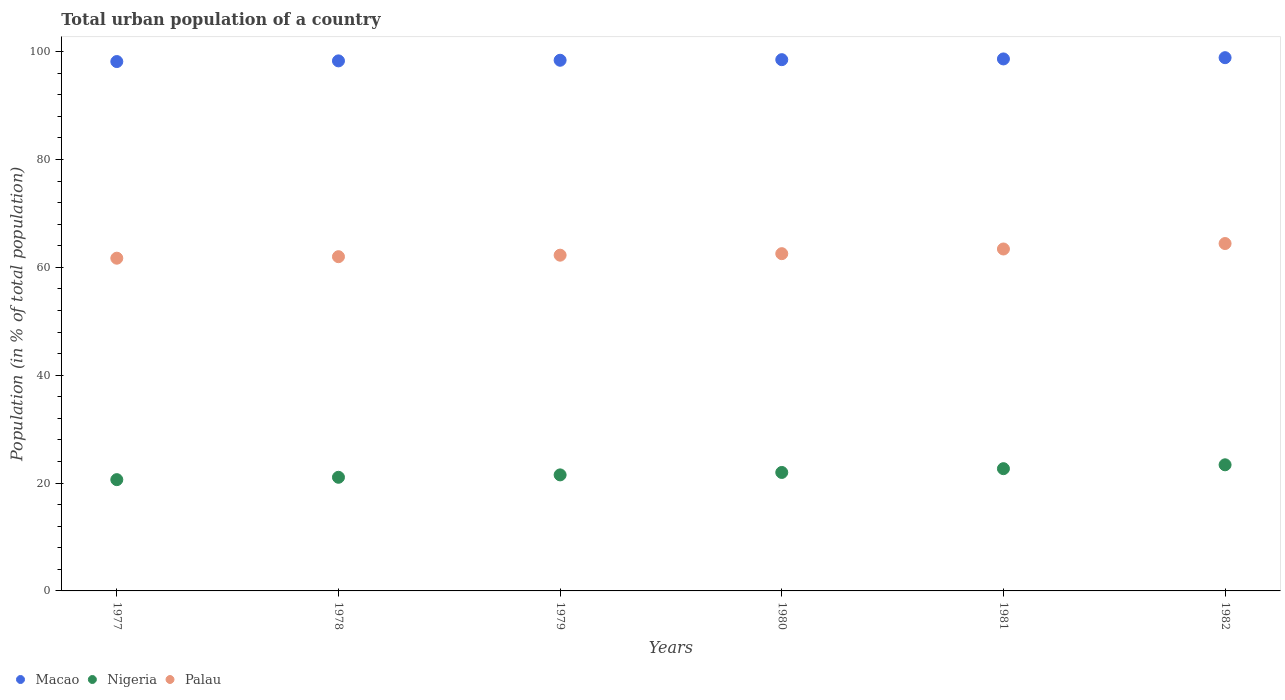What is the urban population in Palau in 1979?
Your answer should be compact. 62.26. Across all years, what is the maximum urban population in Nigeria?
Ensure brevity in your answer.  23.39. Across all years, what is the minimum urban population in Palau?
Your answer should be very brief. 61.7. In which year was the urban population in Palau maximum?
Your answer should be very brief. 1982. What is the total urban population in Palau in the graph?
Your answer should be very brief. 376.32. What is the difference between the urban population in Palau in 1979 and that in 1982?
Offer a very short reply. -2.16. What is the difference between the urban population in Macao in 1981 and the urban population in Nigeria in 1980?
Your answer should be very brief. 76.69. What is the average urban population in Nigeria per year?
Give a very brief answer. 21.88. In the year 1979, what is the difference between the urban population in Palau and urban population in Macao?
Your response must be concise. -36.15. In how many years, is the urban population in Nigeria greater than 40 %?
Offer a terse response. 0. What is the ratio of the urban population in Nigeria in 1979 to that in 1982?
Give a very brief answer. 0.92. What is the difference between the highest and the second highest urban population in Nigeria?
Give a very brief answer. 0.72. What is the difference between the highest and the lowest urban population in Nigeria?
Ensure brevity in your answer.  2.75. In how many years, is the urban population in Palau greater than the average urban population in Palau taken over all years?
Keep it short and to the point. 2. Does the urban population in Nigeria monotonically increase over the years?
Offer a terse response. Yes. How many dotlines are there?
Give a very brief answer. 3. What is the difference between two consecutive major ticks on the Y-axis?
Your answer should be compact. 20. Does the graph contain any zero values?
Provide a succinct answer. No. Where does the legend appear in the graph?
Offer a very short reply. Bottom left. How many legend labels are there?
Your answer should be compact. 3. How are the legend labels stacked?
Your response must be concise. Horizontal. What is the title of the graph?
Your answer should be compact. Total urban population of a country. Does "Least developed countries" appear as one of the legend labels in the graph?
Your answer should be compact. No. What is the label or title of the Y-axis?
Your response must be concise. Population (in % of total population). What is the Population (in % of total population) of Macao in 1977?
Your answer should be very brief. 98.17. What is the Population (in % of total population) in Nigeria in 1977?
Offer a very short reply. 20.64. What is the Population (in % of total population) of Palau in 1977?
Give a very brief answer. 61.7. What is the Population (in % of total population) in Macao in 1978?
Offer a terse response. 98.29. What is the Population (in % of total population) of Nigeria in 1978?
Offer a very short reply. 21.07. What is the Population (in % of total population) in Palau in 1978?
Keep it short and to the point. 61.98. What is the Population (in % of total population) of Macao in 1979?
Provide a succinct answer. 98.41. What is the Population (in % of total population) in Nigeria in 1979?
Your answer should be compact. 21.52. What is the Population (in % of total population) in Palau in 1979?
Give a very brief answer. 62.26. What is the Population (in % of total population) of Macao in 1980?
Your answer should be very brief. 98.52. What is the Population (in % of total population) of Nigeria in 1980?
Make the answer very short. 21.97. What is the Population (in % of total population) of Palau in 1980?
Provide a succinct answer. 62.54. What is the Population (in % of total population) in Macao in 1981?
Your answer should be very brief. 98.66. What is the Population (in % of total population) in Nigeria in 1981?
Offer a terse response. 22.67. What is the Population (in % of total population) in Palau in 1981?
Ensure brevity in your answer.  63.41. What is the Population (in % of total population) of Macao in 1982?
Offer a very short reply. 98.89. What is the Population (in % of total population) in Nigeria in 1982?
Keep it short and to the point. 23.39. What is the Population (in % of total population) of Palau in 1982?
Ensure brevity in your answer.  64.42. Across all years, what is the maximum Population (in % of total population) of Macao?
Make the answer very short. 98.89. Across all years, what is the maximum Population (in % of total population) in Nigeria?
Offer a terse response. 23.39. Across all years, what is the maximum Population (in % of total population) in Palau?
Your response must be concise. 64.42. Across all years, what is the minimum Population (in % of total population) of Macao?
Your answer should be very brief. 98.17. Across all years, what is the minimum Population (in % of total population) of Nigeria?
Offer a very short reply. 20.64. Across all years, what is the minimum Population (in % of total population) of Palau?
Ensure brevity in your answer.  61.7. What is the total Population (in % of total population) in Macao in the graph?
Offer a very short reply. 590.94. What is the total Population (in % of total population) of Nigeria in the graph?
Offer a very short reply. 131.26. What is the total Population (in % of total population) of Palau in the graph?
Offer a very short reply. 376.32. What is the difference between the Population (in % of total population) in Macao in 1977 and that in 1978?
Keep it short and to the point. -0.12. What is the difference between the Population (in % of total population) of Nigeria in 1977 and that in 1978?
Your response must be concise. -0.44. What is the difference between the Population (in % of total population) of Palau in 1977 and that in 1978?
Your answer should be compact. -0.28. What is the difference between the Population (in % of total population) of Macao in 1977 and that in 1979?
Your answer should be compact. -0.24. What is the difference between the Population (in % of total population) in Nigeria in 1977 and that in 1979?
Make the answer very short. -0.88. What is the difference between the Population (in % of total population) of Palau in 1977 and that in 1979?
Make the answer very short. -0.56. What is the difference between the Population (in % of total population) of Macao in 1977 and that in 1980?
Provide a succinct answer. -0.35. What is the difference between the Population (in % of total population) of Nigeria in 1977 and that in 1980?
Your answer should be compact. -1.33. What is the difference between the Population (in % of total population) of Palau in 1977 and that in 1980?
Ensure brevity in your answer.  -0.84. What is the difference between the Population (in % of total population) in Macao in 1977 and that in 1981?
Provide a succinct answer. -0.49. What is the difference between the Population (in % of total population) in Nigeria in 1977 and that in 1981?
Ensure brevity in your answer.  -2.04. What is the difference between the Population (in % of total population) in Palau in 1977 and that in 1981?
Offer a terse response. -1.71. What is the difference between the Population (in % of total population) of Macao in 1977 and that in 1982?
Provide a short and direct response. -0.72. What is the difference between the Population (in % of total population) in Nigeria in 1977 and that in 1982?
Ensure brevity in your answer.  -2.75. What is the difference between the Population (in % of total population) of Palau in 1977 and that in 1982?
Provide a short and direct response. -2.72. What is the difference between the Population (in % of total population) of Macao in 1978 and that in 1979?
Your answer should be compact. -0.12. What is the difference between the Population (in % of total population) of Nigeria in 1978 and that in 1979?
Make the answer very short. -0.44. What is the difference between the Population (in % of total population) of Palau in 1978 and that in 1979?
Make the answer very short. -0.28. What is the difference between the Population (in % of total population) of Macao in 1978 and that in 1980?
Provide a succinct answer. -0.23. What is the difference between the Population (in % of total population) in Nigeria in 1978 and that in 1980?
Provide a succinct answer. -0.9. What is the difference between the Population (in % of total population) in Palau in 1978 and that in 1980?
Your response must be concise. -0.56. What is the difference between the Population (in % of total population) in Macao in 1978 and that in 1981?
Offer a terse response. -0.36. What is the difference between the Population (in % of total population) in Nigeria in 1978 and that in 1981?
Offer a terse response. -1.6. What is the difference between the Population (in % of total population) of Palau in 1978 and that in 1981?
Your answer should be very brief. -1.43. What is the difference between the Population (in % of total population) of Macao in 1978 and that in 1982?
Make the answer very short. -0.59. What is the difference between the Population (in % of total population) of Nigeria in 1978 and that in 1982?
Ensure brevity in your answer.  -2.31. What is the difference between the Population (in % of total population) in Palau in 1978 and that in 1982?
Make the answer very short. -2.44. What is the difference between the Population (in % of total population) in Macao in 1979 and that in 1980?
Your answer should be very brief. -0.11. What is the difference between the Population (in % of total population) in Nigeria in 1979 and that in 1980?
Ensure brevity in your answer.  -0.45. What is the difference between the Population (in % of total population) of Palau in 1979 and that in 1980?
Make the answer very short. -0.28. What is the difference between the Population (in % of total population) in Macao in 1979 and that in 1981?
Provide a short and direct response. -0.24. What is the difference between the Population (in % of total population) of Nigeria in 1979 and that in 1981?
Make the answer very short. -1.15. What is the difference between the Population (in % of total population) of Palau in 1979 and that in 1981?
Your response must be concise. -1.15. What is the difference between the Population (in % of total population) of Macao in 1979 and that in 1982?
Your answer should be very brief. -0.48. What is the difference between the Population (in % of total population) of Nigeria in 1979 and that in 1982?
Offer a very short reply. -1.87. What is the difference between the Population (in % of total population) in Palau in 1979 and that in 1982?
Make the answer very short. -2.16. What is the difference between the Population (in % of total population) of Macao in 1980 and that in 1981?
Provide a short and direct response. -0.14. What is the difference between the Population (in % of total population) of Nigeria in 1980 and that in 1981?
Provide a short and direct response. -0.7. What is the difference between the Population (in % of total population) of Palau in 1980 and that in 1981?
Your response must be concise. -0.87. What is the difference between the Population (in % of total population) of Macao in 1980 and that in 1982?
Ensure brevity in your answer.  -0.37. What is the difference between the Population (in % of total population) in Nigeria in 1980 and that in 1982?
Provide a short and direct response. -1.42. What is the difference between the Population (in % of total population) in Palau in 1980 and that in 1982?
Ensure brevity in your answer.  -1.88. What is the difference between the Population (in % of total population) in Macao in 1981 and that in 1982?
Your answer should be very brief. -0.23. What is the difference between the Population (in % of total population) of Nigeria in 1981 and that in 1982?
Your answer should be very brief. -0.72. What is the difference between the Population (in % of total population) in Palau in 1981 and that in 1982?
Your response must be concise. -1.01. What is the difference between the Population (in % of total population) of Macao in 1977 and the Population (in % of total population) of Nigeria in 1978?
Your answer should be very brief. 77.09. What is the difference between the Population (in % of total population) of Macao in 1977 and the Population (in % of total population) of Palau in 1978?
Your answer should be compact. 36.19. What is the difference between the Population (in % of total population) in Nigeria in 1977 and the Population (in % of total population) in Palau in 1978?
Your response must be concise. -41.35. What is the difference between the Population (in % of total population) in Macao in 1977 and the Population (in % of total population) in Nigeria in 1979?
Your response must be concise. 76.65. What is the difference between the Population (in % of total population) of Macao in 1977 and the Population (in % of total population) of Palau in 1979?
Your response must be concise. 35.91. What is the difference between the Population (in % of total population) of Nigeria in 1977 and the Population (in % of total population) of Palau in 1979?
Provide a succinct answer. -41.63. What is the difference between the Population (in % of total population) in Macao in 1977 and the Population (in % of total population) in Nigeria in 1980?
Provide a succinct answer. 76.2. What is the difference between the Population (in % of total population) in Macao in 1977 and the Population (in % of total population) in Palau in 1980?
Offer a terse response. 35.63. What is the difference between the Population (in % of total population) in Nigeria in 1977 and the Population (in % of total population) in Palau in 1980?
Give a very brief answer. -41.91. What is the difference between the Population (in % of total population) of Macao in 1977 and the Population (in % of total population) of Nigeria in 1981?
Offer a terse response. 75.5. What is the difference between the Population (in % of total population) in Macao in 1977 and the Population (in % of total population) in Palau in 1981?
Offer a terse response. 34.76. What is the difference between the Population (in % of total population) of Nigeria in 1977 and the Population (in % of total population) of Palau in 1981?
Provide a succinct answer. -42.77. What is the difference between the Population (in % of total population) of Macao in 1977 and the Population (in % of total population) of Nigeria in 1982?
Give a very brief answer. 74.78. What is the difference between the Population (in % of total population) of Macao in 1977 and the Population (in % of total population) of Palau in 1982?
Your answer should be compact. 33.75. What is the difference between the Population (in % of total population) in Nigeria in 1977 and the Population (in % of total population) in Palau in 1982?
Keep it short and to the point. -43.79. What is the difference between the Population (in % of total population) in Macao in 1978 and the Population (in % of total population) in Nigeria in 1979?
Keep it short and to the point. 76.78. What is the difference between the Population (in % of total population) in Macao in 1978 and the Population (in % of total population) in Palau in 1979?
Offer a very short reply. 36.03. What is the difference between the Population (in % of total population) of Nigeria in 1978 and the Population (in % of total population) of Palau in 1979?
Provide a short and direct response. -41.19. What is the difference between the Population (in % of total population) in Macao in 1978 and the Population (in % of total population) in Nigeria in 1980?
Provide a short and direct response. 76.32. What is the difference between the Population (in % of total population) in Macao in 1978 and the Population (in % of total population) in Palau in 1980?
Give a very brief answer. 35.75. What is the difference between the Population (in % of total population) of Nigeria in 1978 and the Population (in % of total population) of Palau in 1980?
Make the answer very short. -41.47. What is the difference between the Population (in % of total population) in Macao in 1978 and the Population (in % of total population) in Nigeria in 1981?
Provide a succinct answer. 75.62. What is the difference between the Population (in % of total population) in Macao in 1978 and the Population (in % of total population) in Palau in 1981?
Your answer should be compact. 34.88. What is the difference between the Population (in % of total population) of Nigeria in 1978 and the Population (in % of total population) of Palau in 1981?
Provide a short and direct response. -42.34. What is the difference between the Population (in % of total population) of Macao in 1978 and the Population (in % of total population) of Nigeria in 1982?
Ensure brevity in your answer.  74.91. What is the difference between the Population (in % of total population) in Macao in 1978 and the Population (in % of total population) in Palau in 1982?
Offer a very short reply. 33.87. What is the difference between the Population (in % of total population) of Nigeria in 1978 and the Population (in % of total population) of Palau in 1982?
Your response must be concise. -43.35. What is the difference between the Population (in % of total population) in Macao in 1979 and the Population (in % of total population) in Nigeria in 1980?
Give a very brief answer. 76.44. What is the difference between the Population (in % of total population) of Macao in 1979 and the Population (in % of total population) of Palau in 1980?
Offer a terse response. 35.87. What is the difference between the Population (in % of total population) in Nigeria in 1979 and the Population (in % of total population) in Palau in 1980?
Provide a succinct answer. -41.02. What is the difference between the Population (in % of total population) of Macao in 1979 and the Population (in % of total population) of Nigeria in 1981?
Your answer should be very brief. 75.74. What is the difference between the Population (in % of total population) of Macao in 1979 and the Population (in % of total population) of Palau in 1981?
Ensure brevity in your answer.  35. What is the difference between the Population (in % of total population) in Nigeria in 1979 and the Population (in % of total population) in Palau in 1981?
Ensure brevity in your answer.  -41.89. What is the difference between the Population (in % of total population) of Macao in 1979 and the Population (in % of total population) of Nigeria in 1982?
Ensure brevity in your answer.  75.02. What is the difference between the Population (in % of total population) of Macao in 1979 and the Population (in % of total population) of Palau in 1982?
Give a very brief answer. 33.99. What is the difference between the Population (in % of total population) of Nigeria in 1979 and the Population (in % of total population) of Palau in 1982?
Ensure brevity in your answer.  -42.9. What is the difference between the Population (in % of total population) of Macao in 1980 and the Population (in % of total population) of Nigeria in 1981?
Provide a succinct answer. 75.85. What is the difference between the Population (in % of total population) of Macao in 1980 and the Population (in % of total population) of Palau in 1981?
Offer a terse response. 35.11. What is the difference between the Population (in % of total population) in Nigeria in 1980 and the Population (in % of total population) in Palau in 1981?
Make the answer very short. -41.44. What is the difference between the Population (in % of total population) in Macao in 1980 and the Population (in % of total population) in Nigeria in 1982?
Provide a short and direct response. 75.13. What is the difference between the Population (in % of total population) of Macao in 1980 and the Population (in % of total population) of Palau in 1982?
Offer a very short reply. 34.1. What is the difference between the Population (in % of total population) in Nigeria in 1980 and the Population (in % of total population) in Palau in 1982?
Make the answer very short. -42.45. What is the difference between the Population (in % of total population) of Macao in 1981 and the Population (in % of total population) of Nigeria in 1982?
Keep it short and to the point. 75.27. What is the difference between the Population (in % of total population) in Macao in 1981 and the Population (in % of total population) in Palau in 1982?
Give a very brief answer. 34.23. What is the difference between the Population (in % of total population) of Nigeria in 1981 and the Population (in % of total population) of Palau in 1982?
Provide a short and direct response. -41.75. What is the average Population (in % of total population) in Macao per year?
Give a very brief answer. 98.49. What is the average Population (in % of total population) of Nigeria per year?
Your answer should be compact. 21.88. What is the average Population (in % of total population) in Palau per year?
Offer a terse response. 62.72. In the year 1977, what is the difference between the Population (in % of total population) in Macao and Population (in % of total population) in Nigeria?
Provide a short and direct response. 77.53. In the year 1977, what is the difference between the Population (in % of total population) of Macao and Population (in % of total population) of Palau?
Your answer should be compact. 36.47. In the year 1977, what is the difference between the Population (in % of total population) of Nigeria and Population (in % of total population) of Palau?
Your answer should be compact. -41.07. In the year 1978, what is the difference between the Population (in % of total population) of Macao and Population (in % of total population) of Nigeria?
Make the answer very short. 77.22. In the year 1978, what is the difference between the Population (in % of total population) in Macao and Population (in % of total population) in Palau?
Provide a succinct answer. 36.31. In the year 1978, what is the difference between the Population (in % of total population) of Nigeria and Population (in % of total population) of Palau?
Keep it short and to the point. -40.91. In the year 1979, what is the difference between the Population (in % of total population) in Macao and Population (in % of total population) in Nigeria?
Offer a very short reply. 76.89. In the year 1979, what is the difference between the Population (in % of total population) of Macao and Population (in % of total population) of Palau?
Give a very brief answer. 36.15. In the year 1979, what is the difference between the Population (in % of total population) of Nigeria and Population (in % of total population) of Palau?
Offer a very short reply. -40.74. In the year 1980, what is the difference between the Population (in % of total population) in Macao and Population (in % of total population) in Nigeria?
Offer a very short reply. 76.55. In the year 1980, what is the difference between the Population (in % of total population) of Macao and Population (in % of total population) of Palau?
Offer a very short reply. 35.98. In the year 1980, what is the difference between the Population (in % of total population) of Nigeria and Population (in % of total population) of Palau?
Keep it short and to the point. -40.57. In the year 1981, what is the difference between the Population (in % of total population) of Macao and Population (in % of total population) of Nigeria?
Keep it short and to the point. 75.98. In the year 1981, what is the difference between the Population (in % of total population) of Macao and Population (in % of total population) of Palau?
Give a very brief answer. 35.25. In the year 1981, what is the difference between the Population (in % of total population) of Nigeria and Population (in % of total population) of Palau?
Your response must be concise. -40.74. In the year 1982, what is the difference between the Population (in % of total population) in Macao and Population (in % of total population) in Nigeria?
Your answer should be very brief. 75.5. In the year 1982, what is the difference between the Population (in % of total population) in Macao and Population (in % of total population) in Palau?
Offer a terse response. 34.47. In the year 1982, what is the difference between the Population (in % of total population) in Nigeria and Population (in % of total population) in Palau?
Provide a short and direct response. -41.03. What is the ratio of the Population (in % of total population) in Nigeria in 1977 to that in 1978?
Offer a very short reply. 0.98. What is the ratio of the Population (in % of total population) in Palau in 1977 to that in 1978?
Provide a succinct answer. 1. What is the ratio of the Population (in % of total population) of Macao in 1977 to that in 1979?
Offer a terse response. 1. What is the ratio of the Population (in % of total population) in Macao in 1977 to that in 1980?
Give a very brief answer. 1. What is the ratio of the Population (in % of total population) in Nigeria in 1977 to that in 1980?
Keep it short and to the point. 0.94. What is the ratio of the Population (in % of total population) of Palau in 1977 to that in 1980?
Ensure brevity in your answer.  0.99. What is the ratio of the Population (in % of total population) in Macao in 1977 to that in 1981?
Ensure brevity in your answer.  1. What is the ratio of the Population (in % of total population) of Nigeria in 1977 to that in 1981?
Your answer should be very brief. 0.91. What is the ratio of the Population (in % of total population) of Palau in 1977 to that in 1981?
Provide a succinct answer. 0.97. What is the ratio of the Population (in % of total population) in Nigeria in 1977 to that in 1982?
Provide a succinct answer. 0.88. What is the ratio of the Population (in % of total population) in Palau in 1977 to that in 1982?
Offer a terse response. 0.96. What is the ratio of the Population (in % of total population) in Macao in 1978 to that in 1979?
Keep it short and to the point. 1. What is the ratio of the Population (in % of total population) of Nigeria in 1978 to that in 1979?
Ensure brevity in your answer.  0.98. What is the ratio of the Population (in % of total population) of Palau in 1978 to that in 1979?
Make the answer very short. 1. What is the ratio of the Population (in % of total population) of Nigeria in 1978 to that in 1980?
Your answer should be very brief. 0.96. What is the ratio of the Population (in % of total population) of Palau in 1978 to that in 1980?
Give a very brief answer. 0.99. What is the ratio of the Population (in % of total population) of Nigeria in 1978 to that in 1981?
Ensure brevity in your answer.  0.93. What is the ratio of the Population (in % of total population) in Palau in 1978 to that in 1981?
Keep it short and to the point. 0.98. What is the ratio of the Population (in % of total population) of Nigeria in 1978 to that in 1982?
Your response must be concise. 0.9. What is the ratio of the Population (in % of total population) of Palau in 1978 to that in 1982?
Give a very brief answer. 0.96. What is the ratio of the Population (in % of total population) in Nigeria in 1979 to that in 1980?
Ensure brevity in your answer.  0.98. What is the ratio of the Population (in % of total population) of Nigeria in 1979 to that in 1981?
Make the answer very short. 0.95. What is the ratio of the Population (in % of total population) in Palau in 1979 to that in 1981?
Your answer should be very brief. 0.98. What is the ratio of the Population (in % of total population) of Palau in 1979 to that in 1982?
Offer a terse response. 0.97. What is the ratio of the Population (in % of total population) in Macao in 1980 to that in 1981?
Keep it short and to the point. 1. What is the ratio of the Population (in % of total population) in Nigeria in 1980 to that in 1981?
Provide a succinct answer. 0.97. What is the ratio of the Population (in % of total population) in Palau in 1980 to that in 1981?
Provide a short and direct response. 0.99. What is the ratio of the Population (in % of total population) in Nigeria in 1980 to that in 1982?
Make the answer very short. 0.94. What is the ratio of the Population (in % of total population) in Palau in 1980 to that in 1982?
Ensure brevity in your answer.  0.97. What is the ratio of the Population (in % of total population) of Macao in 1981 to that in 1982?
Your answer should be very brief. 1. What is the ratio of the Population (in % of total population) in Nigeria in 1981 to that in 1982?
Offer a very short reply. 0.97. What is the ratio of the Population (in % of total population) in Palau in 1981 to that in 1982?
Ensure brevity in your answer.  0.98. What is the difference between the highest and the second highest Population (in % of total population) in Macao?
Keep it short and to the point. 0.23. What is the difference between the highest and the second highest Population (in % of total population) of Nigeria?
Ensure brevity in your answer.  0.72. What is the difference between the highest and the lowest Population (in % of total population) of Macao?
Your answer should be very brief. 0.72. What is the difference between the highest and the lowest Population (in % of total population) of Nigeria?
Offer a terse response. 2.75. What is the difference between the highest and the lowest Population (in % of total population) of Palau?
Provide a short and direct response. 2.72. 